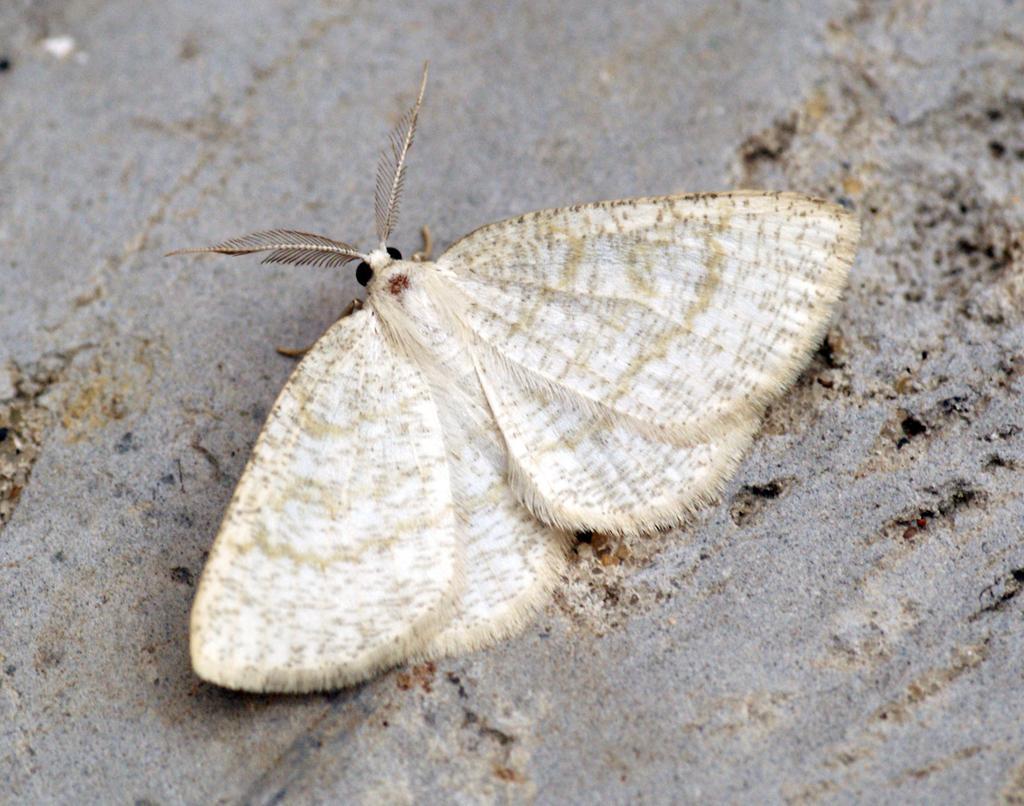How would you summarize this image in a sentence or two? In this picture in the middle, we can see a butterfly which is in white color. In the background, there is a sand. 